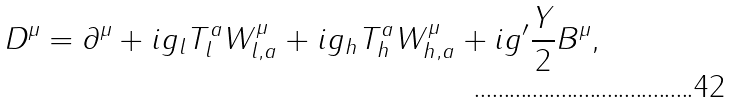<formula> <loc_0><loc_0><loc_500><loc_500>D ^ { \mu } = \partial ^ { \mu } + i g _ { l } T ^ { a } _ { l } W ^ { \mu } _ { l , a } + i g _ { h } T ^ { a } _ { h } W ^ { \mu } _ { h , a } + i g ^ { \prime } \frac { Y } { 2 } B ^ { \mu } ,</formula> 